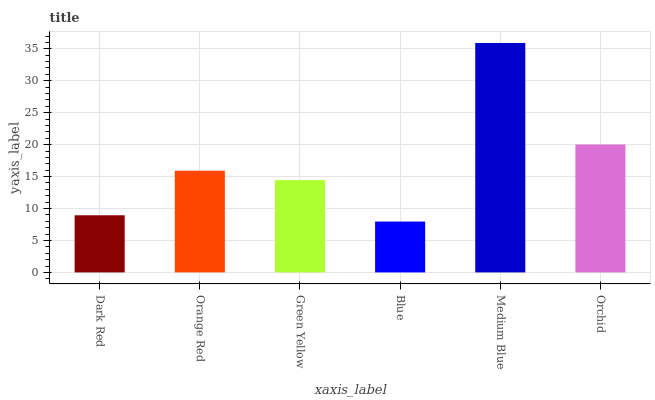Is Blue the minimum?
Answer yes or no. Yes. Is Medium Blue the maximum?
Answer yes or no. Yes. Is Orange Red the minimum?
Answer yes or no. No. Is Orange Red the maximum?
Answer yes or no. No. Is Orange Red greater than Dark Red?
Answer yes or no. Yes. Is Dark Red less than Orange Red?
Answer yes or no. Yes. Is Dark Red greater than Orange Red?
Answer yes or no. No. Is Orange Red less than Dark Red?
Answer yes or no. No. Is Orange Red the high median?
Answer yes or no. Yes. Is Green Yellow the low median?
Answer yes or no. Yes. Is Orchid the high median?
Answer yes or no. No. Is Blue the low median?
Answer yes or no. No. 